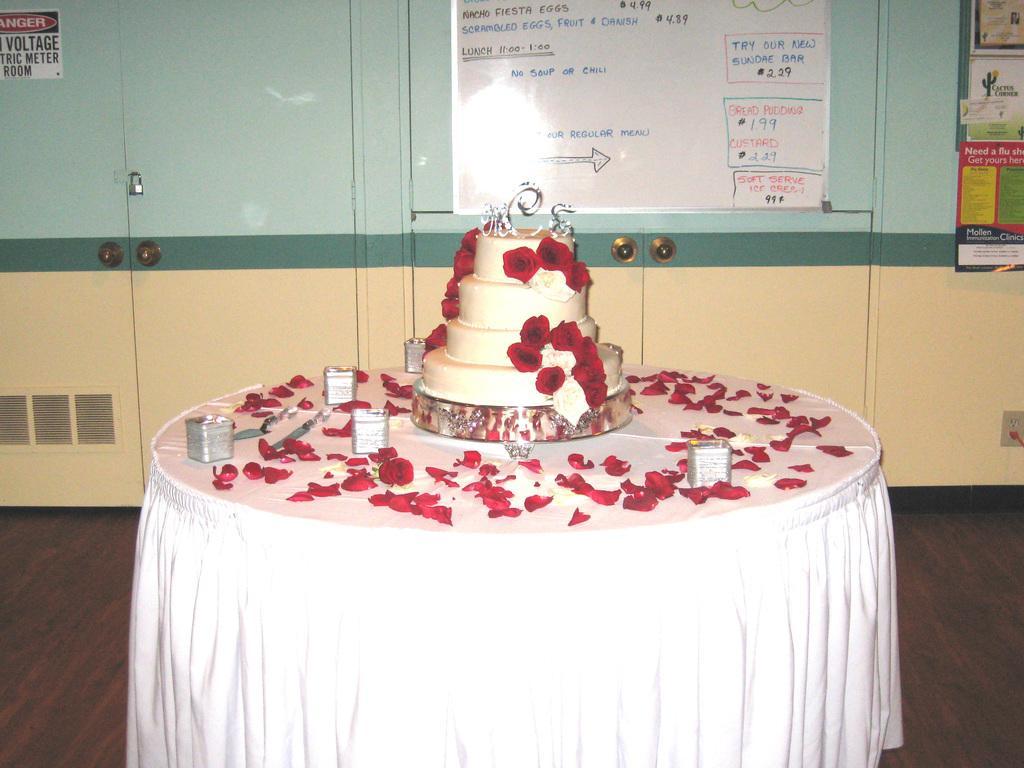Could you give a brief overview of what you see in this image? There is a step cake on which, there are red color rose flowers arranged on the table. Which is covered with white color cloth on which, there are pieces of red color rose flowers and silver color plates arranged. In the background, there is a white color board. Which is attached to the wall. On which, there are posters. 